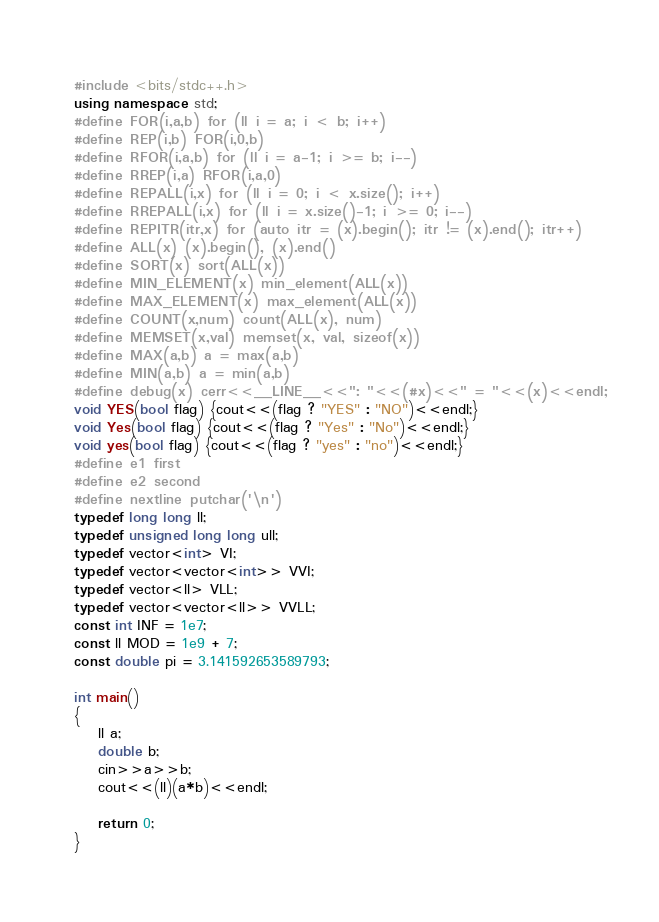<code> <loc_0><loc_0><loc_500><loc_500><_C++_>#include <bits/stdc++.h>
using namespace std;
#define FOR(i,a,b) for (ll i = a; i < b; i++)
#define REP(i,b) FOR(i,0,b)
#define RFOR(i,a,b) for (ll i = a-1; i >= b; i--)
#define RREP(i,a) RFOR(i,a,0)
#define REPALL(i,x) for (ll i = 0; i < x.size(); i++)
#define RREPALL(i,x) for (ll i = x.size()-1; i >= 0; i--)
#define REPITR(itr,x) for (auto itr = (x).begin(); itr != (x).end(); itr++)
#define ALL(x) (x).begin(), (x).end()
#define SORT(x) sort(ALL(x))
#define MIN_ELEMENT(x) min_element(ALL(x))
#define MAX_ELEMENT(x) max_element(ALL(x))
#define COUNT(x,num) count(ALL(x), num)
#define MEMSET(x,val) memset(x, val, sizeof(x))
#define MAX(a,b) a = max(a,b)
#define MIN(a,b) a = min(a,b)
#define debug(x) cerr<<__LINE__<<": "<<(#x)<<" = "<<(x)<<endl;
void YES(bool flag) {cout<<(flag ? "YES" : "NO")<<endl;}
void Yes(bool flag) {cout<<(flag ? "Yes" : "No")<<endl;}
void yes(bool flag) {cout<<(flag ? "yes" : "no")<<endl;}
#define e1 first
#define e2 second
#define nextline putchar('\n')
typedef long long ll;
typedef unsigned long long ull;
typedef vector<int> VI;
typedef vector<vector<int>> VVI;
typedef vector<ll> VLL;
typedef vector<vector<ll>> VVLL;
const int INF = 1e7;
const ll MOD = 1e9 + 7;
const double pi = 3.141592653589793;

int main()
{
    ll a;
    double b;
    cin>>a>>b;
    cout<<(ll)(a*b)<<endl;

    return 0;
}
</code> 